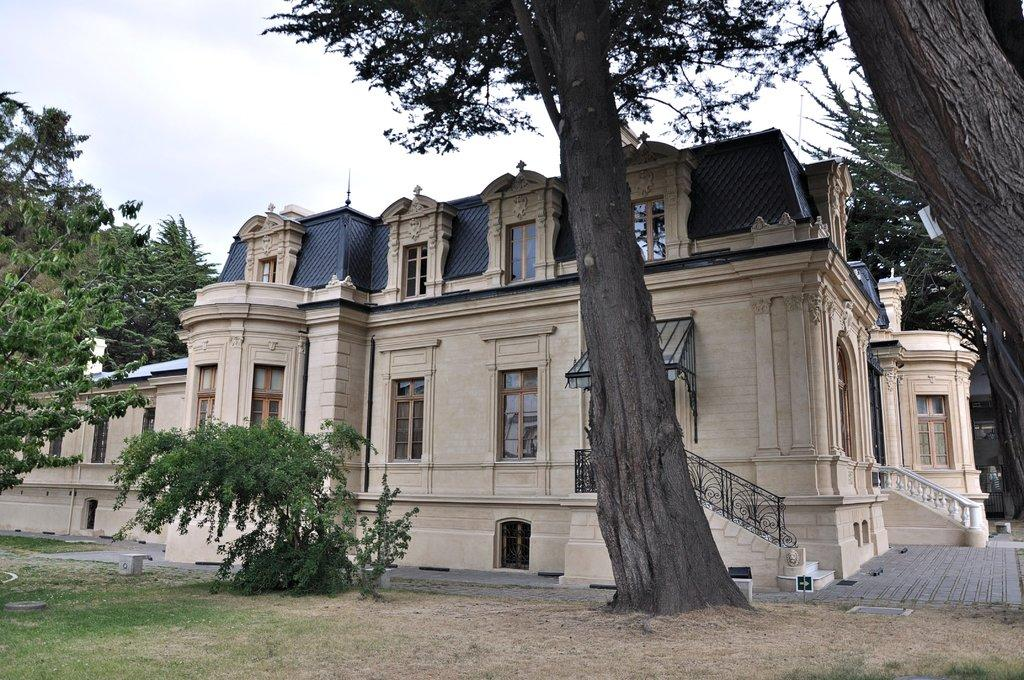What type of structure is present in the image? There is a building in the image. What architectural feature can be seen in the image? There are stairs in the image. What type of vegetation is present in the image? There are trees and a plant in the image. What is visible at the top of the image? The sky is visible at the top of the image. What type of icicle can be seen hanging from the building in the image? There is no icicle present in the image; it is not cold enough for icicles to form. 